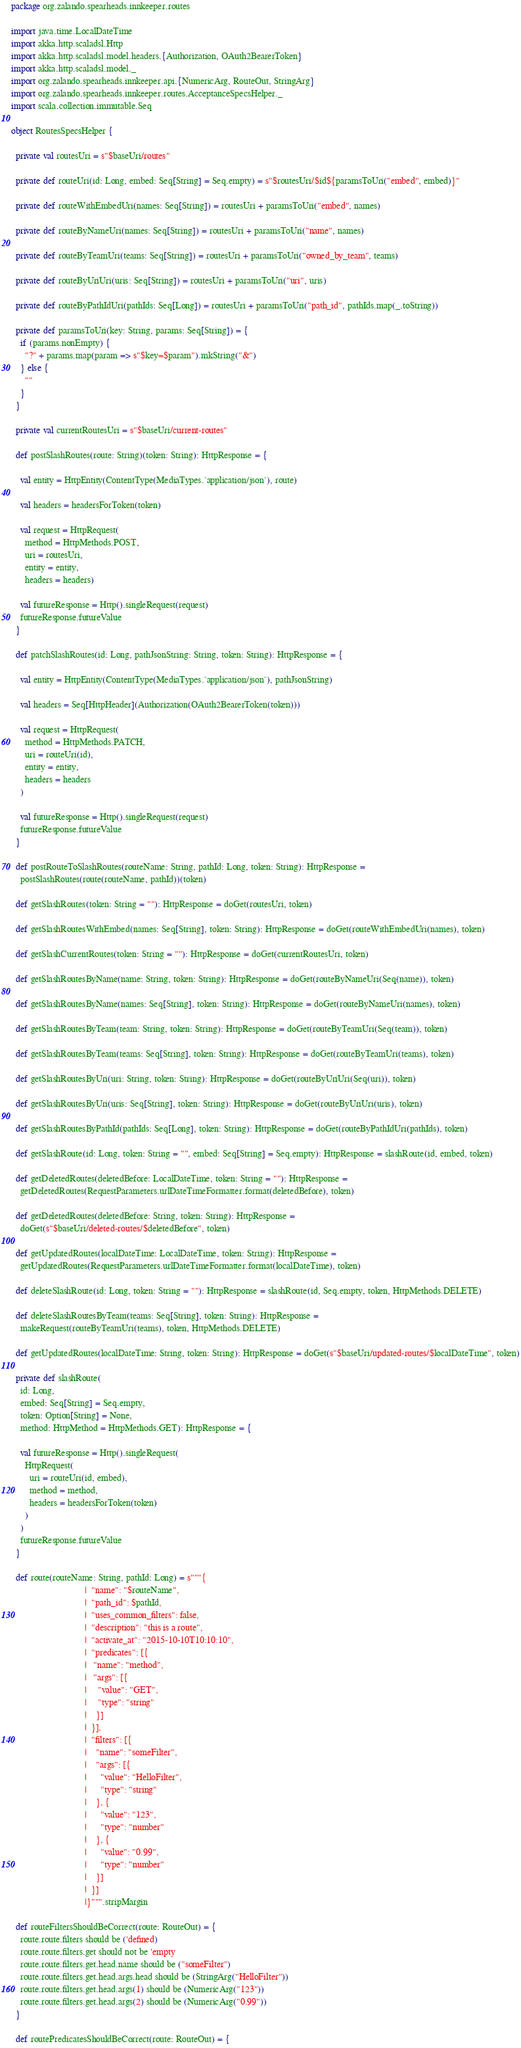Convert code to text. <code><loc_0><loc_0><loc_500><loc_500><_Scala_>package org.zalando.spearheads.innkeeper.routes

import java.time.LocalDateTime
import akka.http.scaladsl.Http
import akka.http.scaladsl.model.headers.{Authorization, OAuth2BearerToken}
import akka.http.scaladsl.model._
import org.zalando.spearheads.innkeeper.api.{NumericArg, RouteOut, StringArg}
import org.zalando.spearheads.innkeeper.routes.AcceptanceSpecsHelper._
import scala.collection.immutable.Seq

object RoutesSpecsHelper {

  private val routesUri = s"$baseUri/routes"

  private def routeUri(id: Long, embed: Seq[String] = Seq.empty) = s"$routesUri/$id${paramsToUri("embed", embed)}"

  private def routeWithEmbedUri(names: Seq[String]) = routesUri + paramsToUri("embed", names)

  private def routeByNameUri(names: Seq[String]) = routesUri + paramsToUri("name", names)

  private def routeByTeamUri(teams: Seq[String]) = routesUri + paramsToUri("owned_by_team", teams)

  private def routeByUriUri(uris: Seq[String]) = routesUri + paramsToUri("uri", uris)

  private def routeByPathIdUri(pathIds: Seq[Long]) = routesUri + paramsToUri("path_id", pathIds.map(_.toString))

  private def paramsToUri(key: String, params: Seq[String]) = {
    if (params.nonEmpty) {
      "?" + params.map(param => s"$key=$param").mkString("&")
    } else {
      ""
    }
  }

  private val currentRoutesUri = s"$baseUri/current-routes"

  def postSlashRoutes(route: String)(token: String): HttpResponse = {

    val entity = HttpEntity(ContentType(MediaTypes.`application/json`), route)

    val headers = headersForToken(token)

    val request = HttpRequest(
      method = HttpMethods.POST,
      uri = routesUri,
      entity = entity,
      headers = headers)

    val futureResponse = Http().singleRequest(request)
    futureResponse.futureValue
  }

  def patchSlashRoutes(id: Long, pathJsonString: String, token: String): HttpResponse = {

    val entity = HttpEntity(ContentType(MediaTypes.`application/json`), pathJsonString)

    val headers = Seq[HttpHeader](Authorization(OAuth2BearerToken(token)))

    val request = HttpRequest(
      method = HttpMethods.PATCH,
      uri = routeUri(id),
      entity = entity,
      headers = headers
    )

    val futureResponse = Http().singleRequest(request)
    futureResponse.futureValue
  }

  def postRouteToSlashRoutes(routeName: String, pathId: Long, token: String): HttpResponse =
    postSlashRoutes(route(routeName, pathId))(token)

  def getSlashRoutes(token: String = ""): HttpResponse = doGet(routesUri, token)

  def getSlashRoutesWithEmbed(names: Seq[String], token: String): HttpResponse = doGet(routeWithEmbedUri(names), token)

  def getSlashCurrentRoutes(token: String = ""): HttpResponse = doGet(currentRoutesUri, token)

  def getSlashRoutesByName(name: String, token: String): HttpResponse = doGet(routeByNameUri(Seq(name)), token)

  def getSlashRoutesByName(names: Seq[String], token: String): HttpResponse = doGet(routeByNameUri(names), token)

  def getSlashRoutesByTeam(team: String, token: String): HttpResponse = doGet(routeByTeamUri(Seq(team)), token)

  def getSlashRoutesByTeam(teams: Seq[String], token: String): HttpResponse = doGet(routeByTeamUri(teams), token)

  def getSlashRoutesByUri(uri: String, token: String): HttpResponse = doGet(routeByUriUri(Seq(uri)), token)

  def getSlashRoutesByUri(uris: Seq[String], token: String): HttpResponse = doGet(routeByUriUri(uris), token)

  def getSlashRoutesByPathId(pathIds: Seq[Long], token: String): HttpResponse = doGet(routeByPathIdUri(pathIds), token)

  def getSlashRoute(id: Long, token: String = "", embed: Seq[String] = Seq.empty): HttpResponse = slashRoute(id, embed, token)

  def getDeletedRoutes(deletedBefore: LocalDateTime, token: String = ""): HttpResponse =
    getDeletedRoutes(RequestParameters.urlDateTimeFormatter.format(deletedBefore), token)

  def getDeletedRoutes(deletedBefore: String, token: String): HttpResponse =
    doGet(s"$baseUri/deleted-routes/$deletedBefore", token)

  def getUpdatedRoutes(localDateTime: LocalDateTime, token: String): HttpResponse =
    getUpdatedRoutes(RequestParameters.urlDateTimeFormatter.format(localDateTime), token)

  def deleteSlashRoute(id: Long, token: String = ""): HttpResponse = slashRoute(id, Seq.empty, token, HttpMethods.DELETE)

  def deleteSlashRoutesByTeam(teams: Seq[String], token: String): HttpResponse =
    makeRequest(routeByTeamUri(teams), token, HttpMethods.DELETE)

  def getUpdatedRoutes(localDateTime: String, token: String): HttpResponse = doGet(s"$baseUri/updated-routes/$localDateTime", token)

  private def slashRoute(
    id: Long,
    embed: Seq[String] = Seq.empty,
    token: Option[String] = None,
    method: HttpMethod = HttpMethods.GET): HttpResponse = {

    val futureResponse = Http().singleRequest(
      HttpRequest(
        uri = routeUri(id, embed),
        method = method,
        headers = headersForToken(token)
      )
    )
    futureResponse.futureValue
  }

  def route(routeName: String, pathId: Long) = s"""{
                                |  "name": "$routeName",
                                |  "path_id": $pathId,
                                |  "uses_common_filters": false,
                                |  "description": "this is a route",
                                |  "activate_at": "2015-10-10T10:10:10",
                                |  "predicates": [{
                                |   "name": "method",
                                |   "args": [{
                                |     "value": "GET",
                                |     "type": "string"
                                |    }]
                                |  }],
                                |  "filters": [{
                                |    "name": "someFilter",
                                |    "args": [{
                                |      "value": "HelloFilter",
                                |      "type": "string"
                                |    }, {
                                |      "value": "123",
                                |      "type": "number"
                                |    }, {
                                |      "value": "0.99",
                                |      "type": "number"
                                |    }]
                                |  }]
                                |}""".stripMargin

  def routeFiltersShouldBeCorrect(route: RouteOut) = {
    route.route.filters should be ('defined)
    route.route.filters.get should not be 'empty
    route.route.filters.get.head.name should be ("someFilter")
    route.route.filters.get.head.args.head should be (StringArg("HelloFilter"))
    route.route.filters.get.head.args(1) should be (NumericArg("123"))
    route.route.filters.get.head.args(2) should be (NumericArg("0.99"))
  }

  def routePredicatesShouldBeCorrect(route: RouteOut) = {</code> 